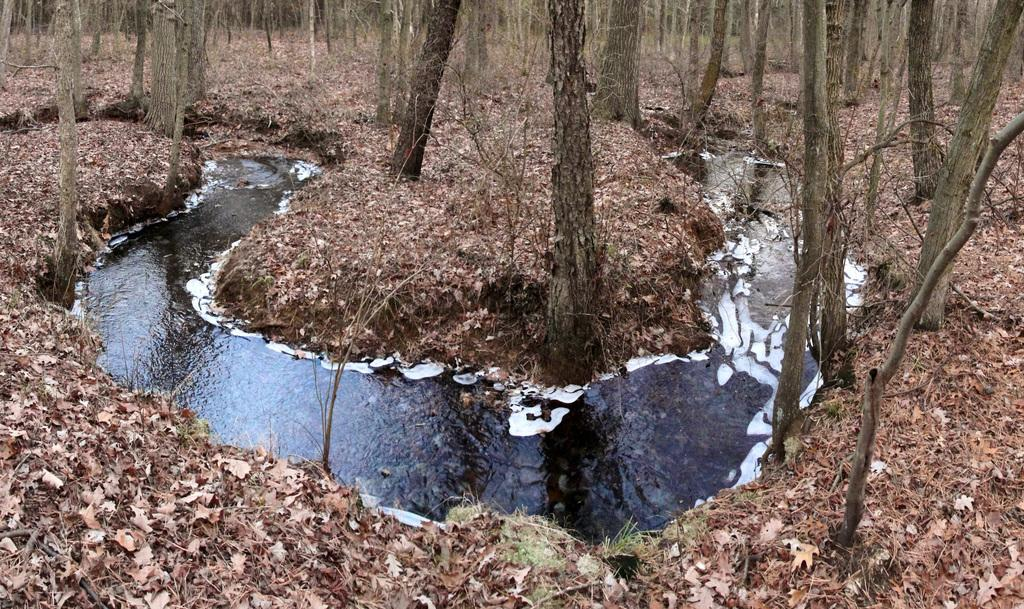What is the primary element visible in the image? There is water in the image. What type of vegetation can be seen in the image? There are trees in the image. What is present on the ground in the image? Leaves are present on the ground in the image. What type of cover is being used to protect the water from the current in the image? There is no mention of a cover or current in the image; it simply shows water, trees, and leaves on the ground. 